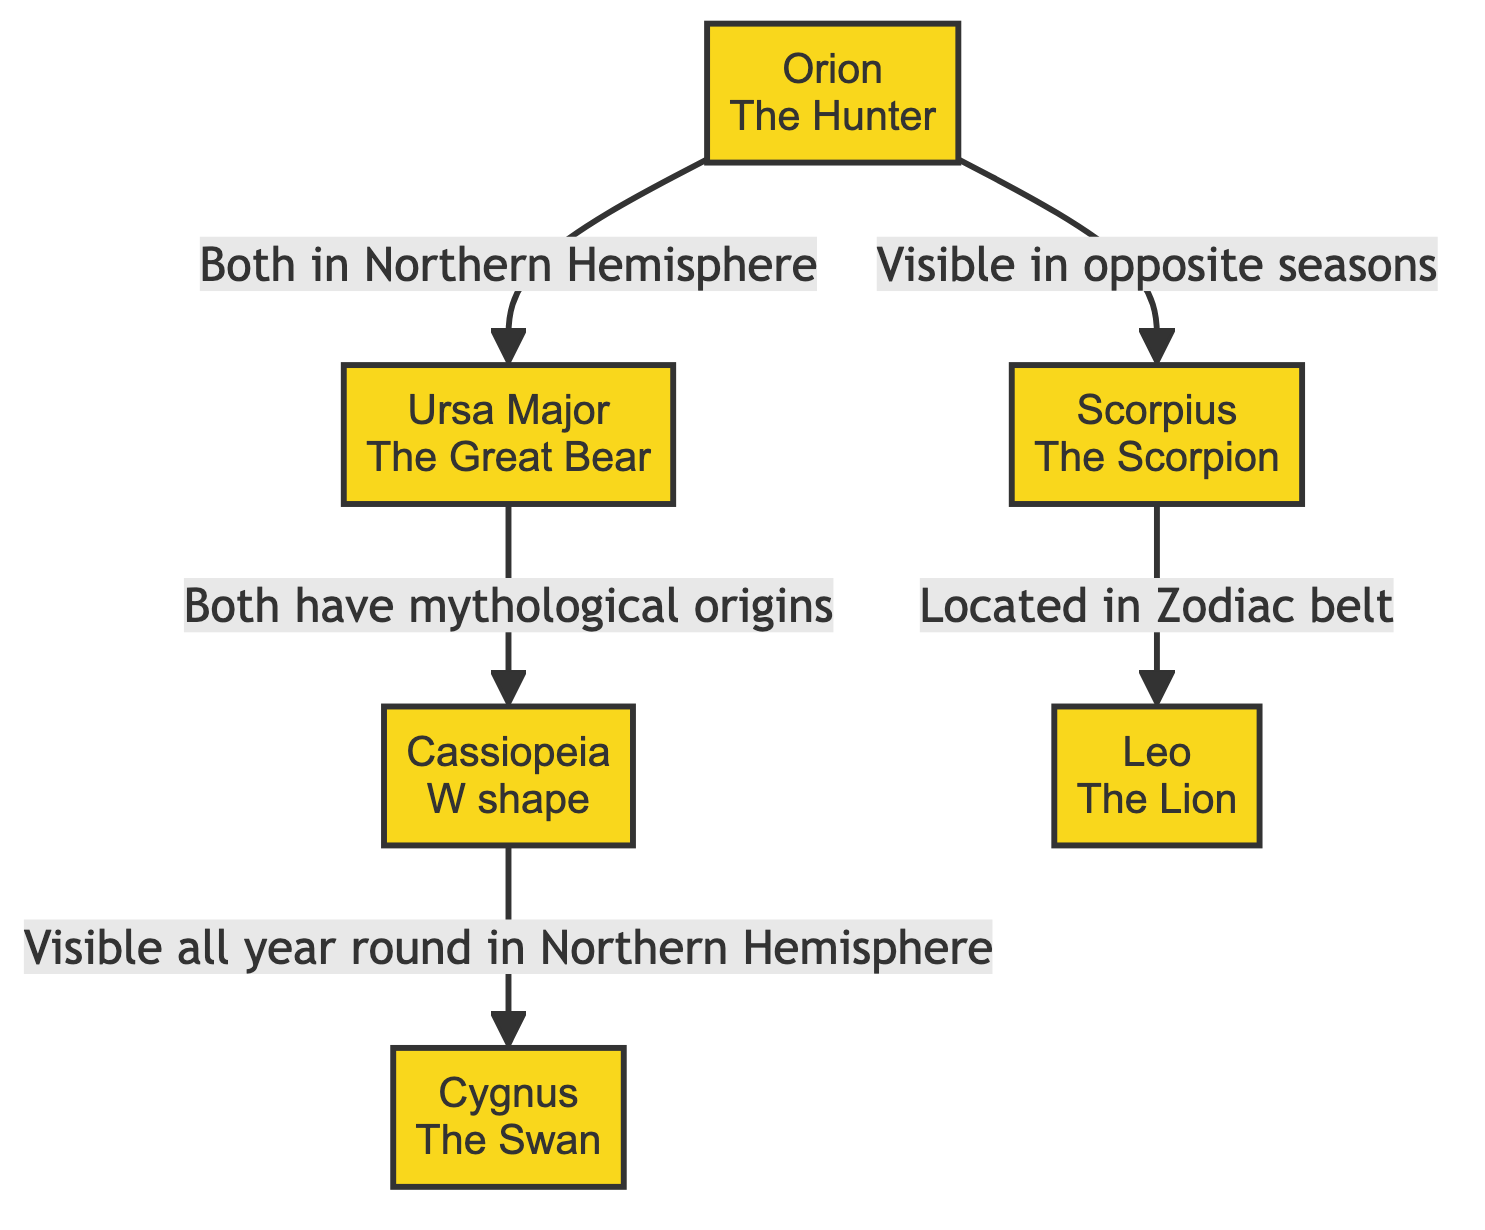What are the major constellations listed in the diagram? The diagram includes the following major constellations: Orion, Ursa Major, Cassiopeia, Scorpius, Leo, and Cygnus. Each constellation is represented with its name in a node.
Answer: Orion, Ursa Major, Cassiopeia, Scorpius, Leo, Cygnus How many constellations are depicted in the diagram? To determine the number of constellations, count the nodes in the diagram. There are a total of six nodes representing the constellations.
Answer: 6 Which constellation is associated with the term "W shape"? The term "W shape" is specifically attributed to Cassiopeia, as indicated in the label of that node within the diagram.
Answer: Cassiopeia Which two constellations are visible in opposite seasons? The diagram shows that Orion and Scorpius are the two constellations visible in opposite seasons, connected by the labeled arrow indicating this relationship.
Answer: Orion and Scorpius Which constellation is stated to be located in the Zodiac belt? The diagram indicates that Leo is the constellation located in the Zodiac belt, as noted in the relationship connecting Scorpius and Leo.
Answer: Leo What is the relationship between Ursa Major and Cassiopeia? The diagram states that Ursa Major and Cassiopeia both have mythological origins, as indicated by the connection labeled between these two constellations.
Answer: Mythological origins Which constellation is visible all year round in the Northern Hemisphere? The relationship indicates that Cygnus is represented as visible all year round in the Northern Hemisphere, as connected to Cassiopeia in the diagram.
Answer: Cygnus How are Orion and Ursa Major related according to the diagram? According to the diagram, Orion and Ursa Major are related by being in the Northern Hemisphere, as indicated by the labeled connecting line between these two constellations.
Answer: Both in Northern Hemisphere 